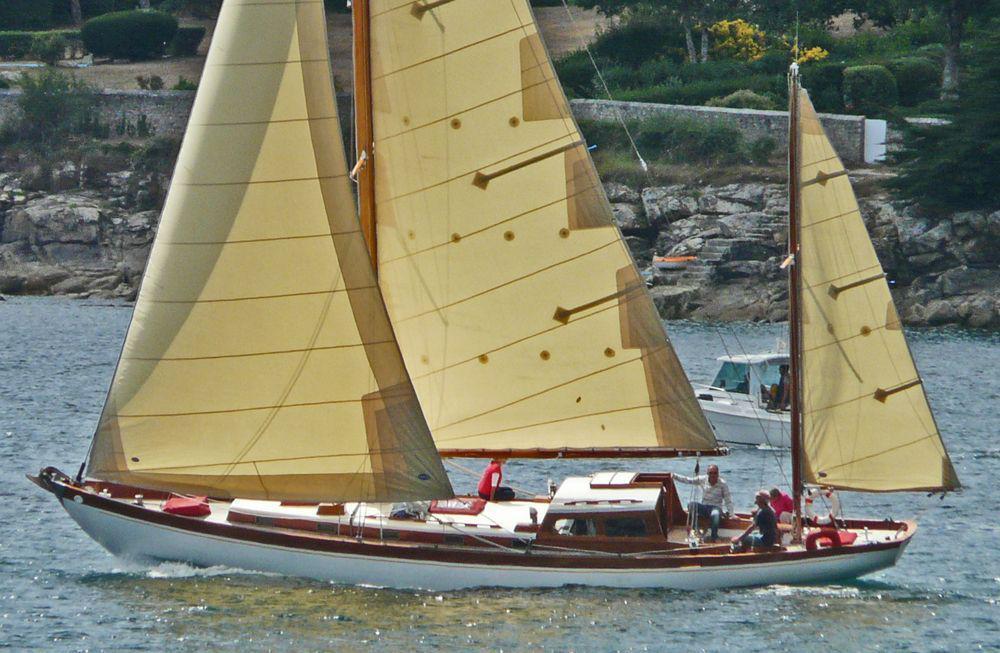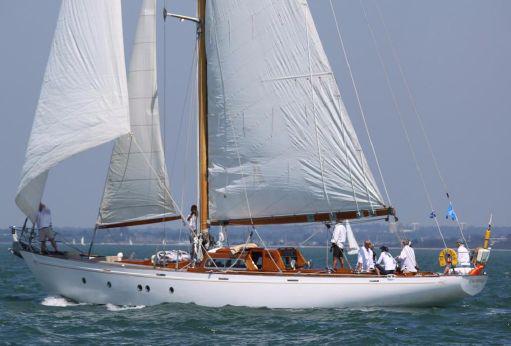The first image is the image on the left, the second image is the image on the right. For the images displayed, is the sentence "In at least one image there is a boat with 3 sails raised" factually correct? Answer yes or no. Yes. The first image is the image on the left, the second image is the image on the right. Evaluate the accuracy of this statement regarding the images: "One image in the pair shows the boat's sails up, the other image shows the sails folded down.". Is it true? Answer yes or no. No. 